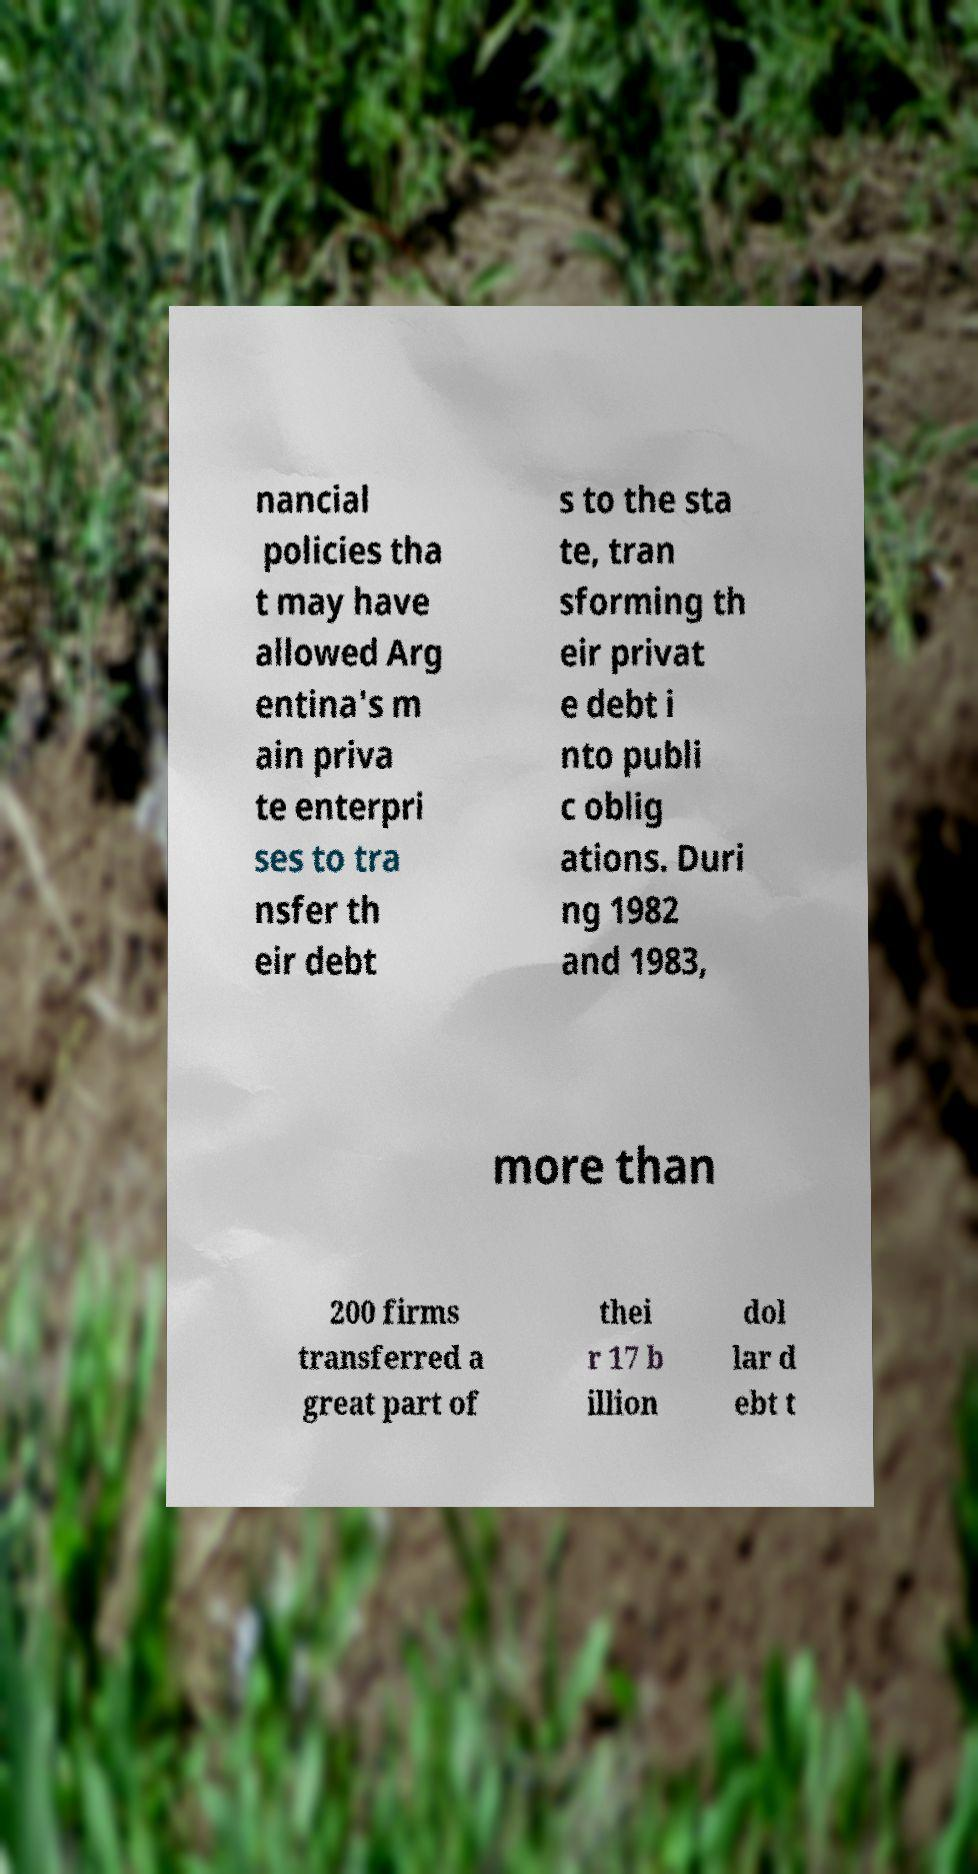Could you assist in decoding the text presented in this image and type it out clearly? nancial policies tha t may have allowed Arg entina's m ain priva te enterpri ses to tra nsfer th eir debt s to the sta te, tran sforming th eir privat e debt i nto publi c oblig ations. Duri ng 1982 and 1983, more than 200 firms transferred a great part of thei r 17 b illion dol lar d ebt t 